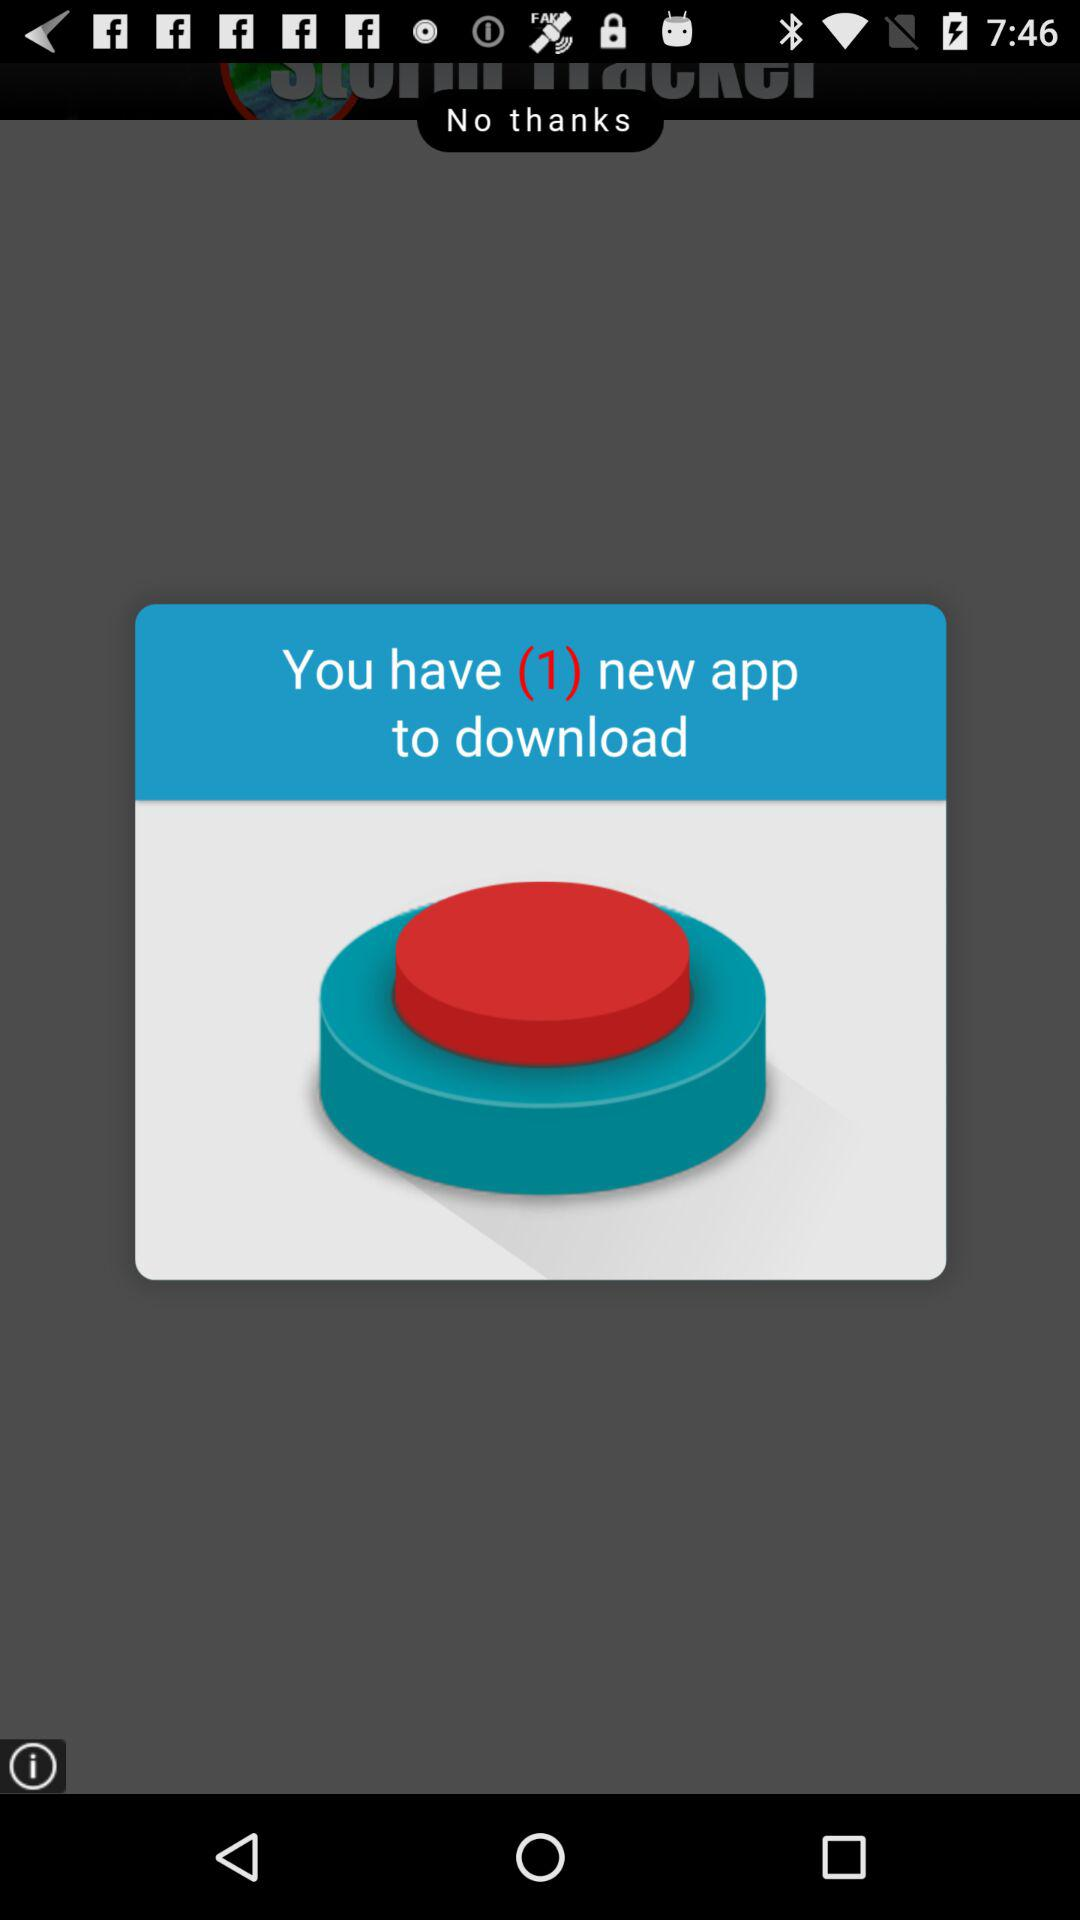How many new apps do I have to download?
Answer the question using a single word or phrase. 1 